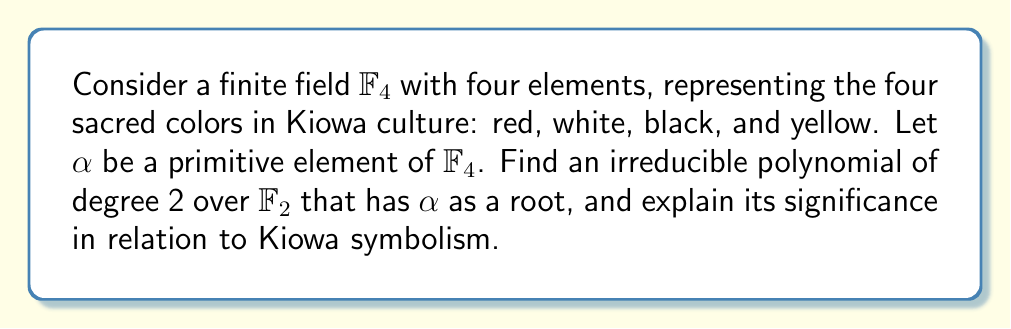Solve this math problem. 1) First, let's construct $\mathbb{F}_4$:
   $\mathbb{F}_4 = \{0, 1, \alpha, \alpha^2\}$, where $\alpha$ is a primitive element.

2) The field $\mathbb{F}_4$ is an extension of $\mathbb{F}_2 = \{0, 1\}$.

3) We know that $\alpha \notin \mathbb{F}_2$, so $\alpha$ must satisfy a quadratic equation over $\mathbb{F}_2$.

4) The general form of a quadratic polynomial over $\mathbb{F}_2$ is:
   $p(x) = x^2 + ax + b$, where $a, b \in \mathbb{F}_2$

5) We need $p(\alpha) = 0$, so:
   $\alpha^2 + a\alpha + b = 0$

6) In $\mathbb{F}_4$, we have $\alpha^2 + \alpha + 1 = 0$ (this is because $\alpha^3 = 1$ in $\mathbb{F}_4$)

7) Therefore, the irreducible polynomial is:
   $p(x) = x^2 + x + 1$

8) Significance in Kiowa symbolism:
   - The degree 2 represents duality in Kiowa culture (e.g., earth and sky).
   - The coefficients (1, 1, 1) can symbolize the unity of the four sacred colors.
   - The irreducibility reflects the indivisible nature of Kiowa spiritual beliefs.
Answer: $x^2 + x + 1$ 